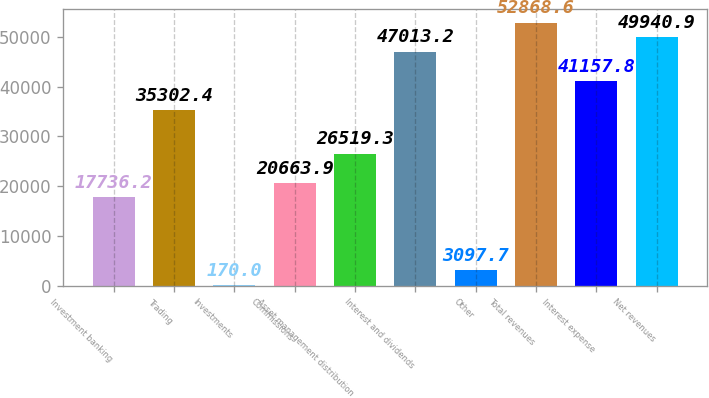<chart> <loc_0><loc_0><loc_500><loc_500><bar_chart><fcel>Investment banking<fcel>Trading<fcel>Investments<fcel>Commissions<fcel>Asset management distribution<fcel>Interest and dividends<fcel>Other<fcel>Total revenues<fcel>Interest expense<fcel>Net revenues<nl><fcel>17736.2<fcel>35302.4<fcel>170<fcel>20663.9<fcel>26519.3<fcel>47013.2<fcel>3097.7<fcel>52868.6<fcel>41157.8<fcel>49940.9<nl></chart> 